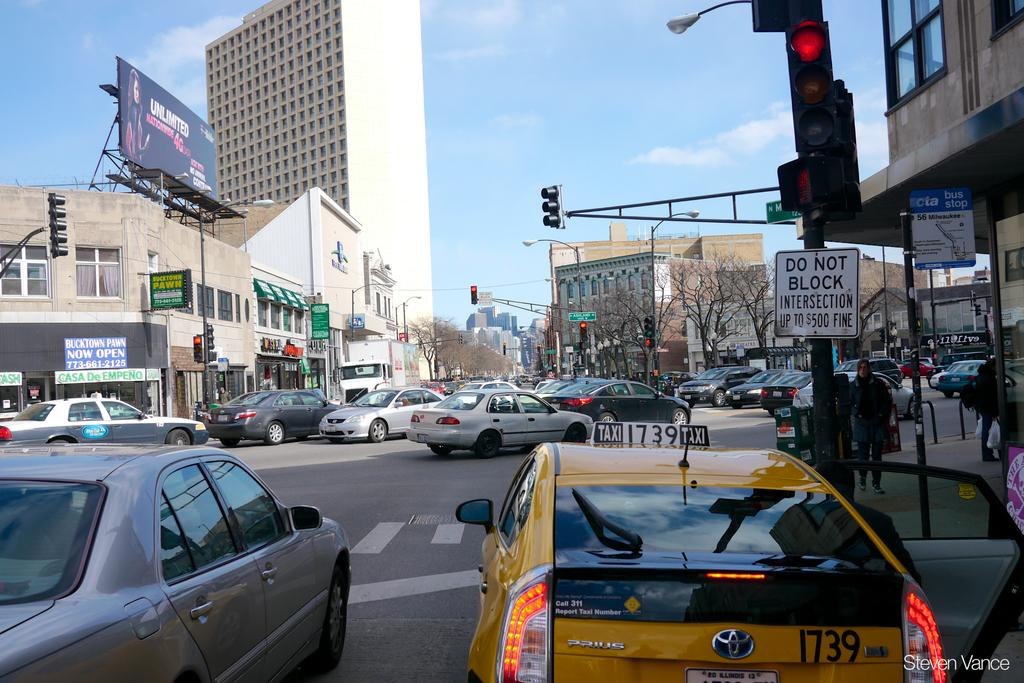<image>
Offer a succinct explanation of the picture presented. a do not block sign that is next to the street 